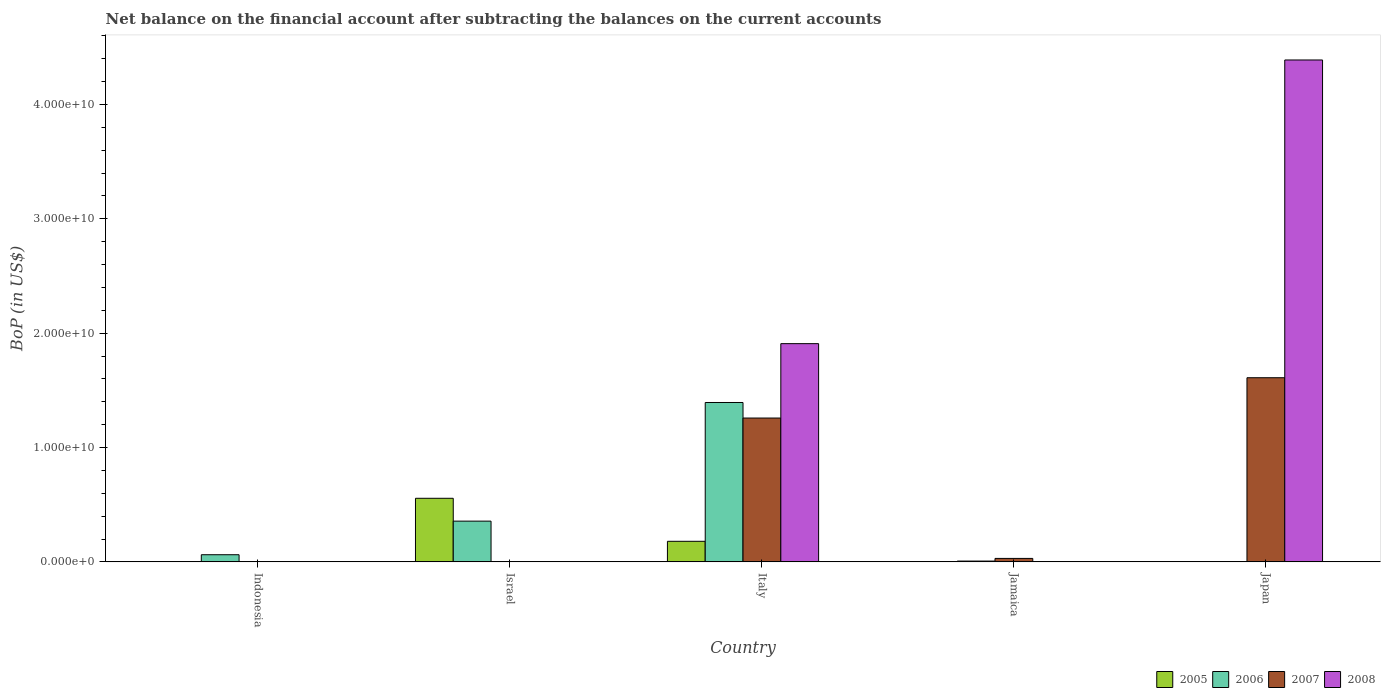How many different coloured bars are there?
Provide a short and direct response. 4. Are the number of bars on each tick of the X-axis equal?
Ensure brevity in your answer.  No. In how many cases, is the number of bars for a given country not equal to the number of legend labels?
Make the answer very short. 4. What is the Balance of Payments in 2005 in Italy?
Make the answer very short. 1.80e+09. Across all countries, what is the maximum Balance of Payments in 2008?
Provide a succinct answer. 4.39e+1. Across all countries, what is the minimum Balance of Payments in 2006?
Give a very brief answer. 0. What is the total Balance of Payments in 2006 in the graph?
Ensure brevity in your answer.  1.82e+1. What is the difference between the Balance of Payments in 2006 in Italy and that in Jamaica?
Your answer should be very brief. 1.39e+1. What is the difference between the Balance of Payments in 2008 in Israel and the Balance of Payments in 2007 in Italy?
Offer a very short reply. -1.26e+1. What is the average Balance of Payments in 2008 per country?
Your response must be concise. 1.26e+1. What is the difference between the Balance of Payments of/in 2007 and Balance of Payments of/in 2008 in Italy?
Keep it short and to the point. -6.51e+09. Is the difference between the Balance of Payments in 2007 in Italy and Japan greater than the difference between the Balance of Payments in 2008 in Italy and Japan?
Your answer should be compact. Yes. What is the difference between the highest and the second highest Balance of Payments in 2006?
Keep it short and to the point. -1.04e+1. What is the difference between the highest and the lowest Balance of Payments in 2006?
Make the answer very short. 1.39e+1. Is the sum of the Balance of Payments in 2007 in Jamaica and Japan greater than the maximum Balance of Payments in 2006 across all countries?
Your answer should be compact. Yes. Is it the case that in every country, the sum of the Balance of Payments in 2007 and Balance of Payments in 2006 is greater than the sum of Balance of Payments in 2005 and Balance of Payments in 2008?
Your answer should be very brief. No. Is it the case that in every country, the sum of the Balance of Payments in 2005 and Balance of Payments in 2007 is greater than the Balance of Payments in 2006?
Keep it short and to the point. No. How many bars are there?
Ensure brevity in your answer.  11. Are all the bars in the graph horizontal?
Provide a short and direct response. No. How many countries are there in the graph?
Offer a terse response. 5. Does the graph contain any zero values?
Your answer should be compact. Yes. Does the graph contain grids?
Keep it short and to the point. No. Where does the legend appear in the graph?
Your response must be concise. Bottom right. How are the legend labels stacked?
Keep it short and to the point. Horizontal. What is the title of the graph?
Keep it short and to the point. Net balance on the financial account after subtracting the balances on the current accounts. What is the label or title of the Y-axis?
Keep it short and to the point. BoP (in US$). What is the BoP (in US$) in 2005 in Indonesia?
Offer a very short reply. 0. What is the BoP (in US$) in 2006 in Indonesia?
Your response must be concise. 6.25e+08. What is the BoP (in US$) in 2007 in Indonesia?
Offer a terse response. 0. What is the BoP (in US$) in 2008 in Indonesia?
Your answer should be very brief. 0. What is the BoP (in US$) in 2005 in Israel?
Provide a short and direct response. 5.56e+09. What is the BoP (in US$) in 2006 in Israel?
Provide a short and direct response. 3.56e+09. What is the BoP (in US$) in 2005 in Italy?
Provide a short and direct response. 1.80e+09. What is the BoP (in US$) in 2006 in Italy?
Keep it short and to the point. 1.39e+1. What is the BoP (in US$) in 2007 in Italy?
Keep it short and to the point. 1.26e+1. What is the BoP (in US$) of 2008 in Italy?
Your response must be concise. 1.91e+1. What is the BoP (in US$) in 2006 in Jamaica?
Your answer should be compact. 7.07e+07. What is the BoP (in US$) in 2007 in Jamaica?
Provide a succinct answer. 3.03e+08. What is the BoP (in US$) of 2006 in Japan?
Give a very brief answer. 0. What is the BoP (in US$) in 2007 in Japan?
Keep it short and to the point. 1.61e+1. What is the BoP (in US$) of 2008 in Japan?
Offer a terse response. 4.39e+1. Across all countries, what is the maximum BoP (in US$) of 2005?
Keep it short and to the point. 5.56e+09. Across all countries, what is the maximum BoP (in US$) of 2006?
Make the answer very short. 1.39e+1. Across all countries, what is the maximum BoP (in US$) in 2007?
Provide a short and direct response. 1.61e+1. Across all countries, what is the maximum BoP (in US$) of 2008?
Your response must be concise. 4.39e+1. Across all countries, what is the minimum BoP (in US$) in 2008?
Offer a very short reply. 0. What is the total BoP (in US$) in 2005 in the graph?
Give a very brief answer. 7.36e+09. What is the total BoP (in US$) in 2006 in the graph?
Make the answer very short. 1.82e+1. What is the total BoP (in US$) in 2007 in the graph?
Your answer should be very brief. 2.90e+1. What is the total BoP (in US$) in 2008 in the graph?
Give a very brief answer. 6.30e+1. What is the difference between the BoP (in US$) in 2006 in Indonesia and that in Israel?
Your answer should be very brief. -2.94e+09. What is the difference between the BoP (in US$) of 2006 in Indonesia and that in Italy?
Your answer should be very brief. -1.33e+1. What is the difference between the BoP (in US$) in 2006 in Indonesia and that in Jamaica?
Make the answer very short. 5.55e+08. What is the difference between the BoP (in US$) in 2005 in Israel and that in Italy?
Keep it short and to the point. 3.76e+09. What is the difference between the BoP (in US$) of 2006 in Israel and that in Italy?
Ensure brevity in your answer.  -1.04e+1. What is the difference between the BoP (in US$) in 2006 in Israel and that in Jamaica?
Offer a terse response. 3.49e+09. What is the difference between the BoP (in US$) of 2006 in Italy and that in Jamaica?
Ensure brevity in your answer.  1.39e+1. What is the difference between the BoP (in US$) in 2007 in Italy and that in Jamaica?
Provide a succinct answer. 1.23e+1. What is the difference between the BoP (in US$) in 2007 in Italy and that in Japan?
Ensure brevity in your answer.  -3.53e+09. What is the difference between the BoP (in US$) in 2008 in Italy and that in Japan?
Give a very brief answer. -2.48e+1. What is the difference between the BoP (in US$) in 2007 in Jamaica and that in Japan?
Provide a succinct answer. -1.58e+1. What is the difference between the BoP (in US$) in 2006 in Indonesia and the BoP (in US$) in 2007 in Italy?
Your response must be concise. -1.20e+1. What is the difference between the BoP (in US$) of 2006 in Indonesia and the BoP (in US$) of 2008 in Italy?
Keep it short and to the point. -1.85e+1. What is the difference between the BoP (in US$) of 2006 in Indonesia and the BoP (in US$) of 2007 in Jamaica?
Offer a terse response. 3.22e+08. What is the difference between the BoP (in US$) of 2006 in Indonesia and the BoP (in US$) of 2007 in Japan?
Keep it short and to the point. -1.55e+1. What is the difference between the BoP (in US$) of 2006 in Indonesia and the BoP (in US$) of 2008 in Japan?
Provide a succinct answer. -4.33e+1. What is the difference between the BoP (in US$) of 2005 in Israel and the BoP (in US$) of 2006 in Italy?
Provide a succinct answer. -8.38e+09. What is the difference between the BoP (in US$) in 2005 in Israel and the BoP (in US$) in 2007 in Italy?
Your answer should be very brief. -7.02e+09. What is the difference between the BoP (in US$) in 2005 in Israel and the BoP (in US$) in 2008 in Italy?
Provide a short and direct response. -1.35e+1. What is the difference between the BoP (in US$) in 2006 in Israel and the BoP (in US$) in 2007 in Italy?
Give a very brief answer. -9.02e+09. What is the difference between the BoP (in US$) in 2006 in Israel and the BoP (in US$) in 2008 in Italy?
Your response must be concise. -1.55e+1. What is the difference between the BoP (in US$) in 2005 in Israel and the BoP (in US$) in 2006 in Jamaica?
Offer a terse response. 5.49e+09. What is the difference between the BoP (in US$) in 2005 in Israel and the BoP (in US$) in 2007 in Jamaica?
Your answer should be very brief. 5.26e+09. What is the difference between the BoP (in US$) in 2006 in Israel and the BoP (in US$) in 2007 in Jamaica?
Keep it short and to the point. 3.26e+09. What is the difference between the BoP (in US$) in 2005 in Israel and the BoP (in US$) in 2007 in Japan?
Your response must be concise. -1.05e+1. What is the difference between the BoP (in US$) in 2005 in Israel and the BoP (in US$) in 2008 in Japan?
Ensure brevity in your answer.  -3.83e+1. What is the difference between the BoP (in US$) in 2006 in Israel and the BoP (in US$) in 2007 in Japan?
Ensure brevity in your answer.  -1.25e+1. What is the difference between the BoP (in US$) in 2006 in Israel and the BoP (in US$) in 2008 in Japan?
Offer a terse response. -4.03e+1. What is the difference between the BoP (in US$) in 2005 in Italy and the BoP (in US$) in 2006 in Jamaica?
Keep it short and to the point. 1.73e+09. What is the difference between the BoP (in US$) of 2005 in Italy and the BoP (in US$) of 2007 in Jamaica?
Give a very brief answer. 1.50e+09. What is the difference between the BoP (in US$) of 2006 in Italy and the BoP (in US$) of 2007 in Jamaica?
Provide a succinct answer. 1.36e+1. What is the difference between the BoP (in US$) of 2005 in Italy and the BoP (in US$) of 2007 in Japan?
Keep it short and to the point. -1.43e+1. What is the difference between the BoP (in US$) in 2005 in Italy and the BoP (in US$) in 2008 in Japan?
Your answer should be very brief. -4.21e+1. What is the difference between the BoP (in US$) in 2006 in Italy and the BoP (in US$) in 2007 in Japan?
Give a very brief answer. -2.17e+09. What is the difference between the BoP (in US$) of 2006 in Italy and the BoP (in US$) of 2008 in Japan?
Your response must be concise. -3.00e+1. What is the difference between the BoP (in US$) in 2007 in Italy and the BoP (in US$) in 2008 in Japan?
Your response must be concise. -3.13e+1. What is the difference between the BoP (in US$) in 2006 in Jamaica and the BoP (in US$) in 2007 in Japan?
Your answer should be very brief. -1.60e+1. What is the difference between the BoP (in US$) of 2006 in Jamaica and the BoP (in US$) of 2008 in Japan?
Your response must be concise. -4.38e+1. What is the difference between the BoP (in US$) of 2007 in Jamaica and the BoP (in US$) of 2008 in Japan?
Give a very brief answer. -4.36e+1. What is the average BoP (in US$) in 2005 per country?
Your response must be concise. 1.47e+09. What is the average BoP (in US$) in 2006 per country?
Your response must be concise. 3.64e+09. What is the average BoP (in US$) of 2007 per country?
Make the answer very short. 5.80e+09. What is the average BoP (in US$) in 2008 per country?
Offer a very short reply. 1.26e+1. What is the difference between the BoP (in US$) of 2005 and BoP (in US$) of 2006 in Israel?
Keep it short and to the point. 2.00e+09. What is the difference between the BoP (in US$) in 2005 and BoP (in US$) in 2006 in Italy?
Ensure brevity in your answer.  -1.21e+1. What is the difference between the BoP (in US$) of 2005 and BoP (in US$) of 2007 in Italy?
Your response must be concise. -1.08e+1. What is the difference between the BoP (in US$) in 2005 and BoP (in US$) in 2008 in Italy?
Your answer should be very brief. -1.73e+1. What is the difference between the BoP (in US$) of 2006 and BoP (in US$) of 2007 in Italy?
Offer a very short reply. 1.36e+09. What is the difference between the BoP (in US$) in 2006 and BoP (in US$) in 2008 in Italy?
Provide a succinct answer. -5.15e+09. What is the difference between the BoP (in US$) of 2007 and BoP (in US$) of 2008 in Italy?
Give a very brief answer. -6.51e+09. What is the difference between the BoP (in US$) in 2006 and BoP (in US$) in 2007 in Jamaica?
Ensure brevity in your answer.  -2.33e+08. What is the difference between the BoP (in US$) in 2007 and BoP (in US$) in 2008 in Japan?
Make the answer very short. -2.78e+1. What is the ratio of the BoP (in US$) in 2006 in Indonesia to that in Israel?
Provide a short and direct response. 0.18. What is the ratio of the BoP (in US$) in 2006 in Indonesia to that in Italy?
Your answer should be compact. 0.04. What is the ratio of the BoP (in US$) of 2006 in Indonesia to that in Jamaica?
Ensure brevity in your answer.  8.84. What is the ratio of the BoP (in US$) in 2005 in Israel to that in Italy?
Make the answer very short. 3.09. What is the ratio of the BoP (in US$) of 2006 in Israel to that in Italy?
Your response must be concise. 0.26. What is the ratio of the BoP (in US$) of 2006 in Israel to that in Jamaica?
Give a very brief answer. 50.36. What is the ratio of the BoP (in US$) in 2006 in Italy to that in Jamaica?
Your response must be concise. 197.04. What is the ratio of the BoP (in US$) in 2007 in Italy to that in Jamaica?
Your answer should be very brief. 41.48. What is the ratio of the BoP (in US$) in 2007 in Italy to that in Japan?
Provide a succinct answer. 0.78. What is the ratio of the BoP (in US$) in 2008 in Italy to that in Japan?
Offer a very short reply. 0.43. What is the ratio of the BoP (in US$) of 2007 in Jamaica to that in Japan?
Ensure brevity in your answer.  0.02. What is the difference between the highest and the second highest BoP (in US$) of 2006?
Your answer should be very brief. 1.04e+1. What is the difference between the highest and the second highest BoP (in US$) of 2007?
Your answer should be compact. 3.53e+09. What is the difference between the highest and the lowest BoP (in US$) of 2005?
Provide a short and direct response. 5.56e+09. What is the difference between the highest and the lowest BoP (in US$) of 2006?
Provide a short and direct response. 1.39e+1. What is the difference between the highest and the lowest BoP (in US$) of 2007?
Your answer should be very brief. 1.61e+1. What is the difference between the highest and the lowest BoP (in US$) in 2008?
Offer a very short reply. 4.39e+1. 